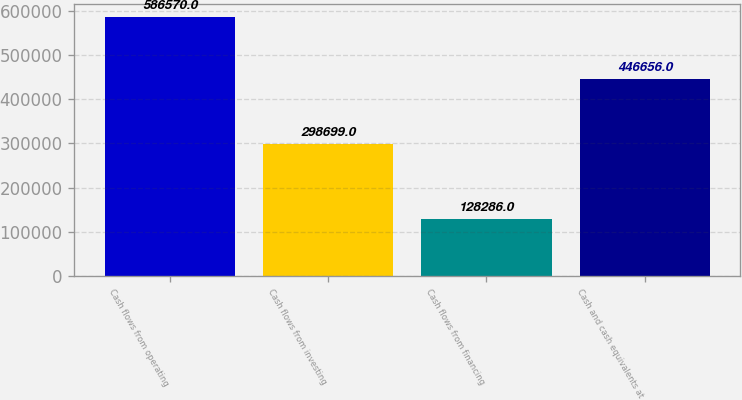Convert chart. <chart><loc_0><loc_0><loc_500><loc_500><bar_chart><fcel>Cash flows from operating<fcel>Cash flows from investing<fcel>Cash flows from financing<fcel>Cash and cash equivalents at<nl><fcel>586570<fcel>298699<fcel>128286<fcel>446656<nl></chart> 